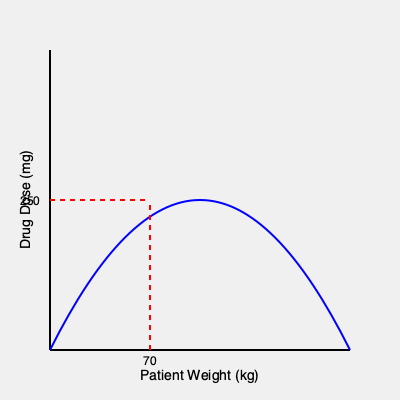Using the nomogram provided, calculate the appropriate drug dose for a patient weighing 70 kg. The nomogram shows the relationship between patient weight and drug dose. What is the recommended drug dose in milligrams? To determine the appropriate drug dose using the nomogram, follow these steps:

1. Locate the patient's weight on the x-axis (horizontal axis):
   - The patient weighs 70 kg, so find the point corresponding to 70 on the x-axis.

2. Draw a vertical line from the 70 kg mark upwards until it intersects with the curved line on the nomogram:
   - This is represented by the red dashed vertical line on the graph.

3. From the point of intersection, draw a horizontal line to the y-axis (vertical axis):
   - This is represented by the red dashed horizontal line on the graph.

4. Read the value on the y-axis where the horizontal line intersects:
   - The line intersects at approximately 250 on the y-axis.

5. Interpret the result:
   - The y-axis represents the drug dose in milligrams (mg).
   - Therefore, the recommended drug dose for a 70 kg patient is 250 mg.

This nomogram allows for quick and accurate dosage calculations based on patient weight, which is crucial in wilderness medicine scenarios where time and resources may be limited.
Answer: 250 mg 